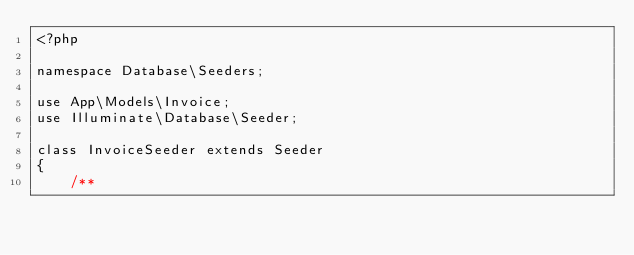Convert code to text. <code><loc_0><loc_0><loc_500><loc_500><_PHP_><?php

namespace Database\Seeders;

use App\Models\Invoice;
use Illuminate\Database\Seeder;

class InvoiceSeeder extends Seeder
{
    /**</code> 